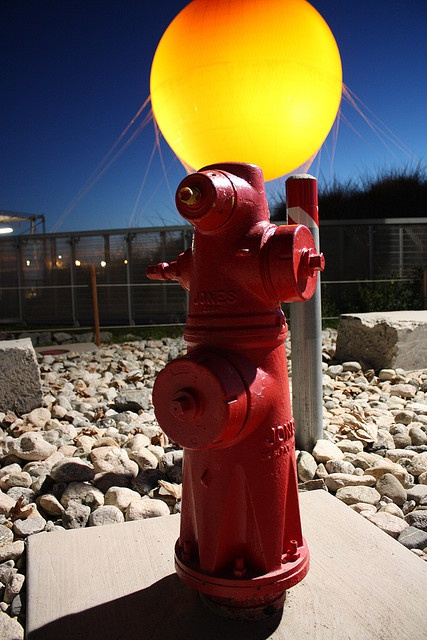Describe the objects in this image and their specific colors. I can see a fire hydrant in black, maroon, brown, and salmon tones in this image. 